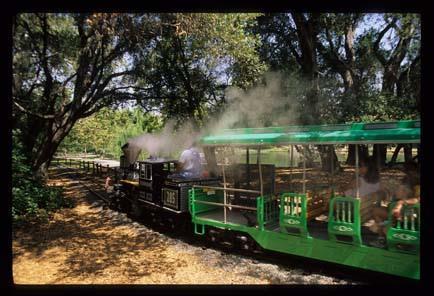What food is the same color as the largest portion of this vehicle?
Indicate the correct choice and explain in the format: 'Answer: answer
Rationale: rationale.'
Options: Corn, lemon, cherry, spinach. Answer: spinach.
Rationale: It is a green vegetable. the train cars are green. 